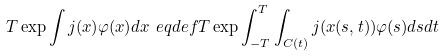<formula> <loc_0><loc_0><loc_500><loc_500>T \exp \int j ( x ) \varphi ( x ) d x \ e q d e f T \exp \int _ { - T } ^ { T } \int _ { C ( t ) } j ( x ( s , t ) ) \varphi ( s ) d s d t</formula> 